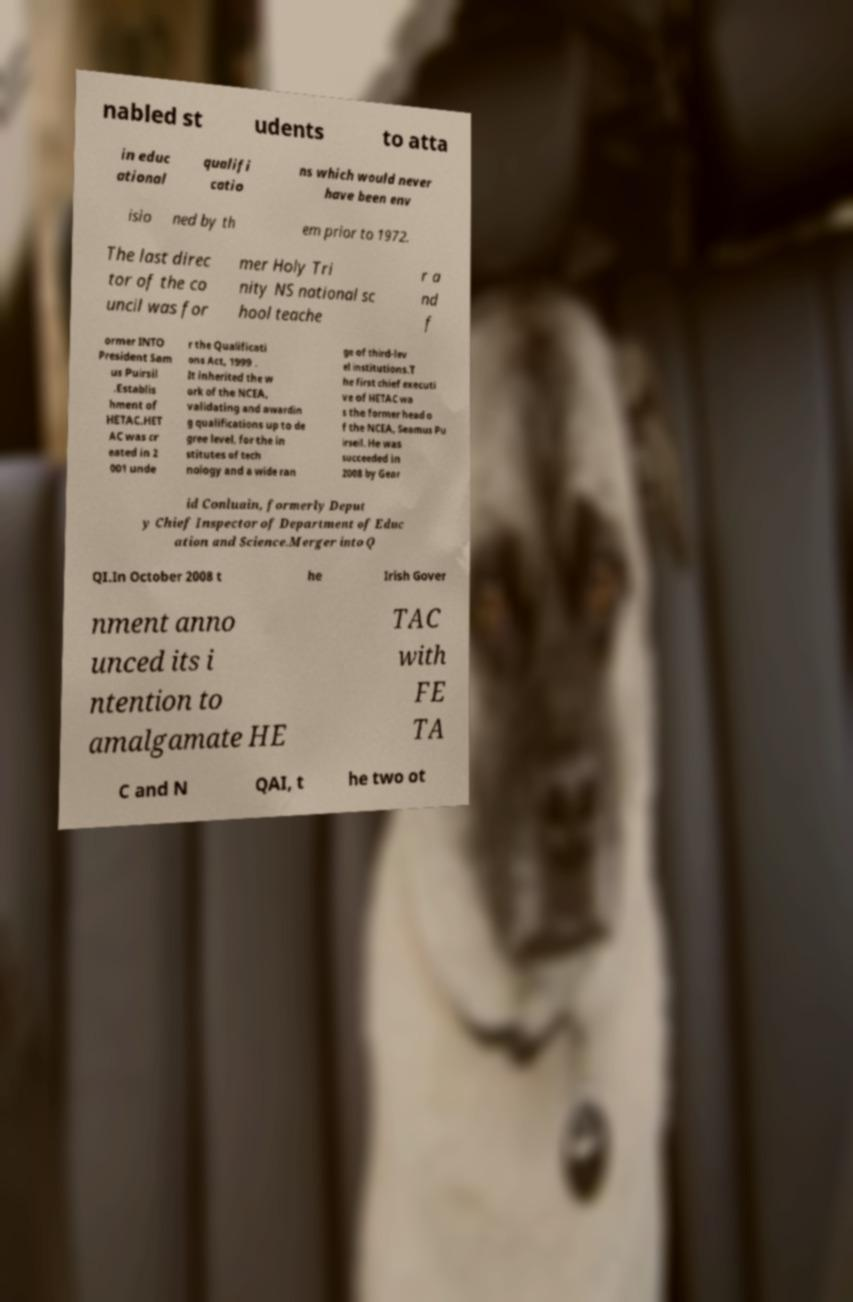Could you extract and type out the text from this image? nabled st udents to atta in educ ational qualifi catio ns which would never have been env isio ned by th em prior to 1972. The last direc tor of the co uncil was for mer Holy Tri nity NS national sc hool teache r a nd f ormer INTO President Sam us Puirsil .Establis hment of HETAC.HET AC was cr eated in 2 001 unde r the Qualificati ons Act, 1999 . It inherited the w ork of the NCEA, validating and awardin g qualifications up to de gree level, for the in stitutes of tech nology and a wide ran ge of third-lev el institutions.T he first chief executi ve of HETAC wa s the former head o f the NCEA, Seamus Pu irseil. He was succeeded in 2008 by Gear id Conluain, formerly Deput y Chief Inspector of Department of Educ ation and Science.Merger into Q QI.In October 2008 t he Irish Gover nment anno unced its i ntention to amalgamate HE TAC with FE TA C and N QAI, t he two ot 